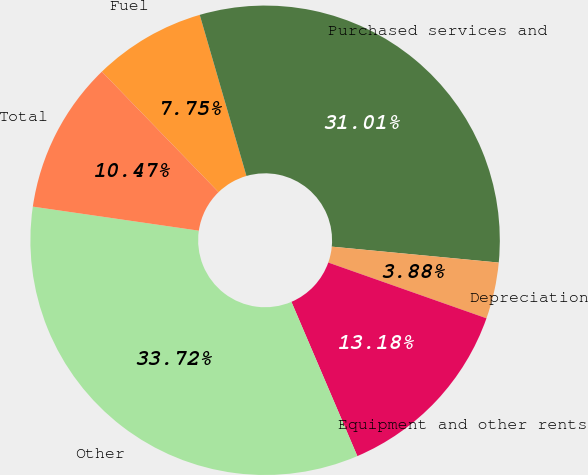<chart> <loc_0><loc_0><loc_500><loc_500><pie_chart><fcel>Fuel<fcel>Purchased services and<fcel>Depreciation<fcel>Equipment and other rents<fcel>Other<fcel>Total<nl><fcel>7.75%<fcel>31.01%<fcel>3.88%<fcel>13.18%<fcel>33.72%<fcel>10.47%<nl></chart> 